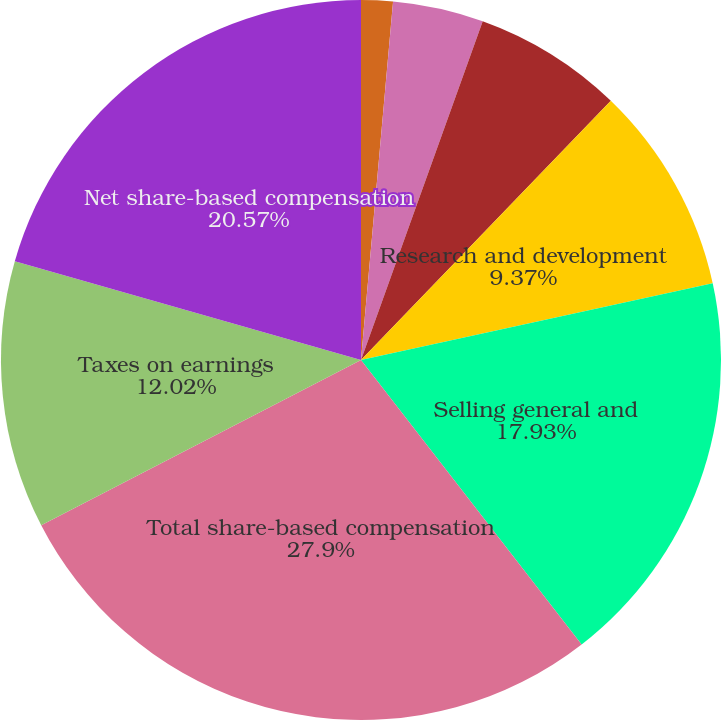Convert chart. <chart><loc_0><loc_0><loc_500><loc_500><pie_chart><fcel>(In thousands)<fcel>Cost of revenues - Product<fcel>Cost of revenues - Service<fcel>Research and development<fcel>Selling general and<fcel>Total share-based compensation<fcel>Taxes on earnings<fcel>Net share-based compensation<nl><fcel>1.42%<fcel>4.07%<fcel>6.72%<fcel>9.37%<fcel>17.93%<fcel>27.91%<fcel>12.02%<fcel>20.58%<nl></chart> 